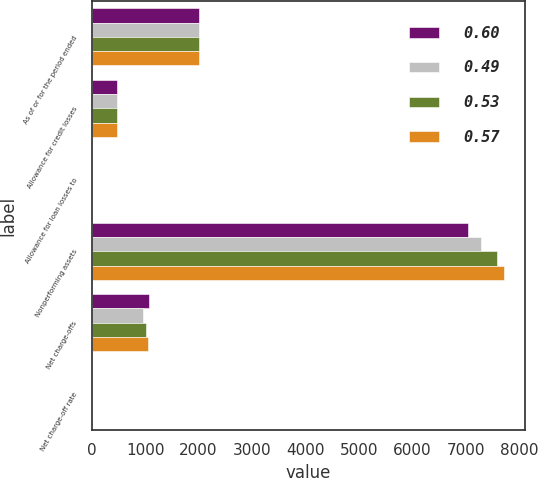Convert chart to OTSL. <chart><loc_0><loc_0><loc_500><loc_500><stacked_bar_chart><ecel><fcel>As of or for the period ended<fcel>Allowance for credit losses<fcel>Allowance for loan losses to<fcel>Nonperforming assets<fcel>Net charge-offs<fcel>Net charge-off rate<nl><fcel>0.6<fcel>2015<fcel>482.43<fcel>1.37<fcel>7034<fcel>1064<fcel>0.52<nl><fcel>0.49<fcel>2015<fcel>482.43<fcel>1.4<fcel>7294<fcel>963<fcel>0.49<nl><fcel>0.53<fcel>2015<fcel>482.43<fcel>1.45<fcel>7588<fcel>1007<fcel>0.53<nl><fcel>0.57<fcel>2015<fcel>482.43<fcel>1.52<fcel>7714<fcel>1052<fcel>0.57<nl></chart> 